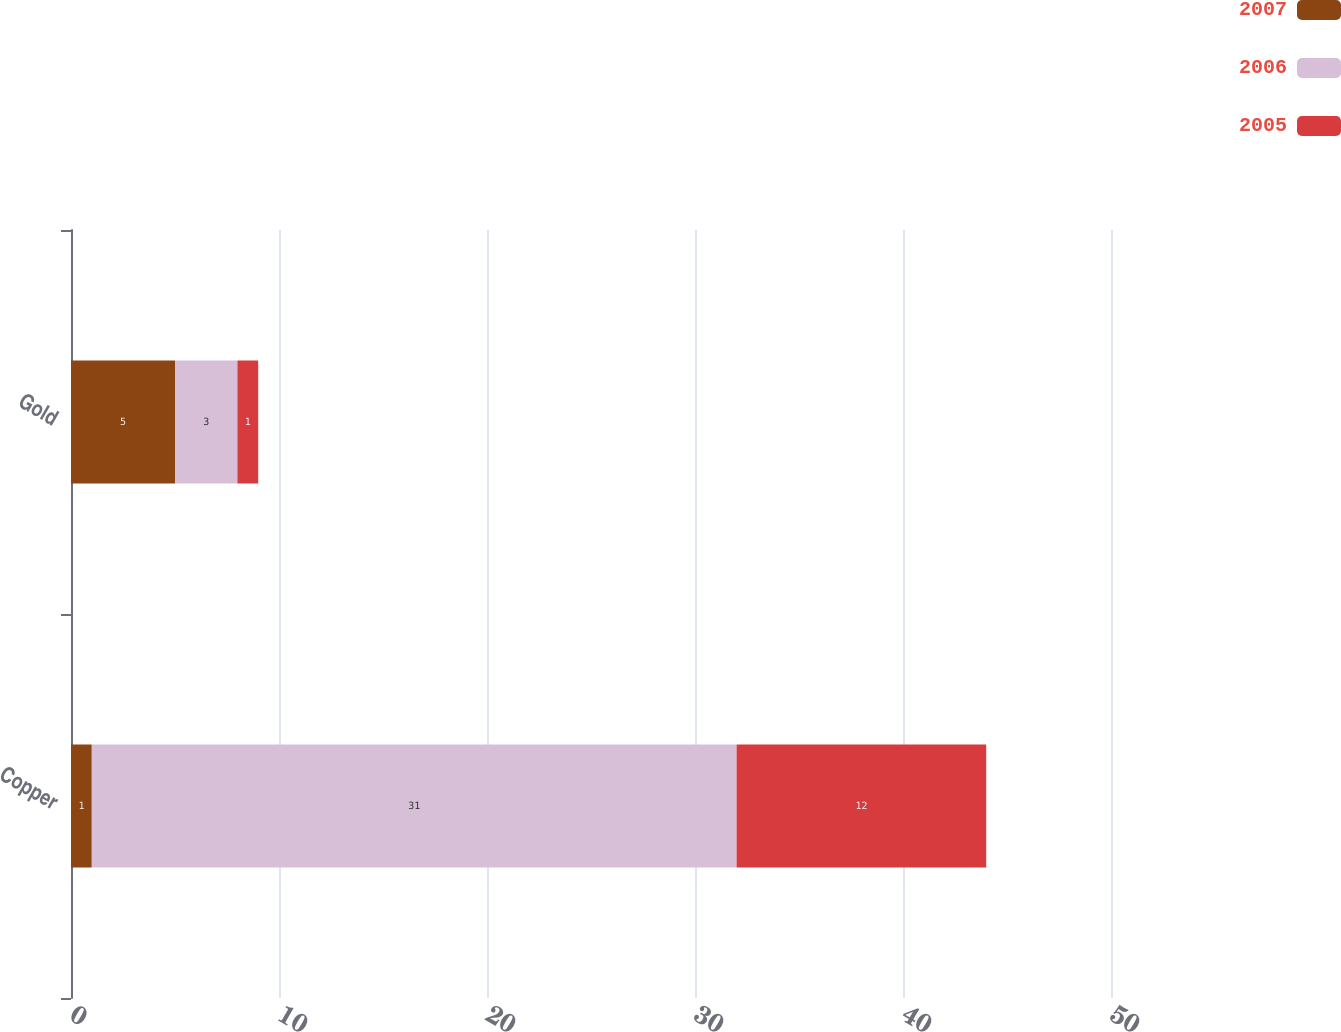Convert chart. <chart><loc_0><loc_0><loc_500><loc_500><stacked_bar_chart><ecel><fcel>Copper<fcel>Gold<nl><fcel>2007<fcel>1<fcel>5<nl><fcel>2006<fcel>31<fcel>3<nl><fcel>2005<fcel>12<fcel>1<nl></chart> 